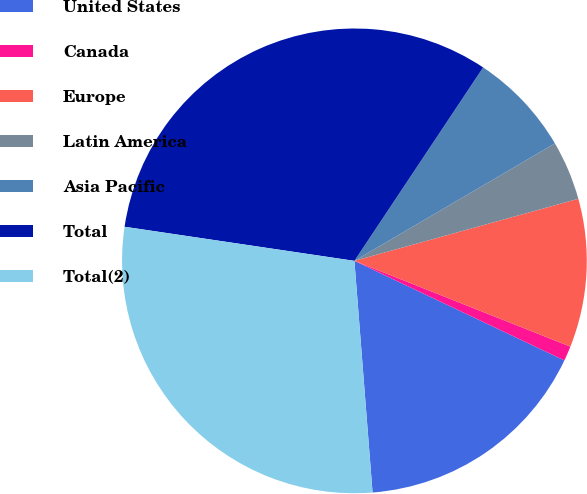Convert chart to OTSL. <chart><loc_0><loc_0><loc_500><loc_500><pie_chart><fcel>United States<fcel>Canada<fcel>Europe<fcel>Latin America<fcel>Asia Pacific<fcel>Total<fcel>Total(2)<nl><fcel>16.71%<fcel>1.03%<fcel>10.32%<fcel>4.13%<fcel>7.22%<fcel>32.0%<fcel>28.59%<nl></chart> 